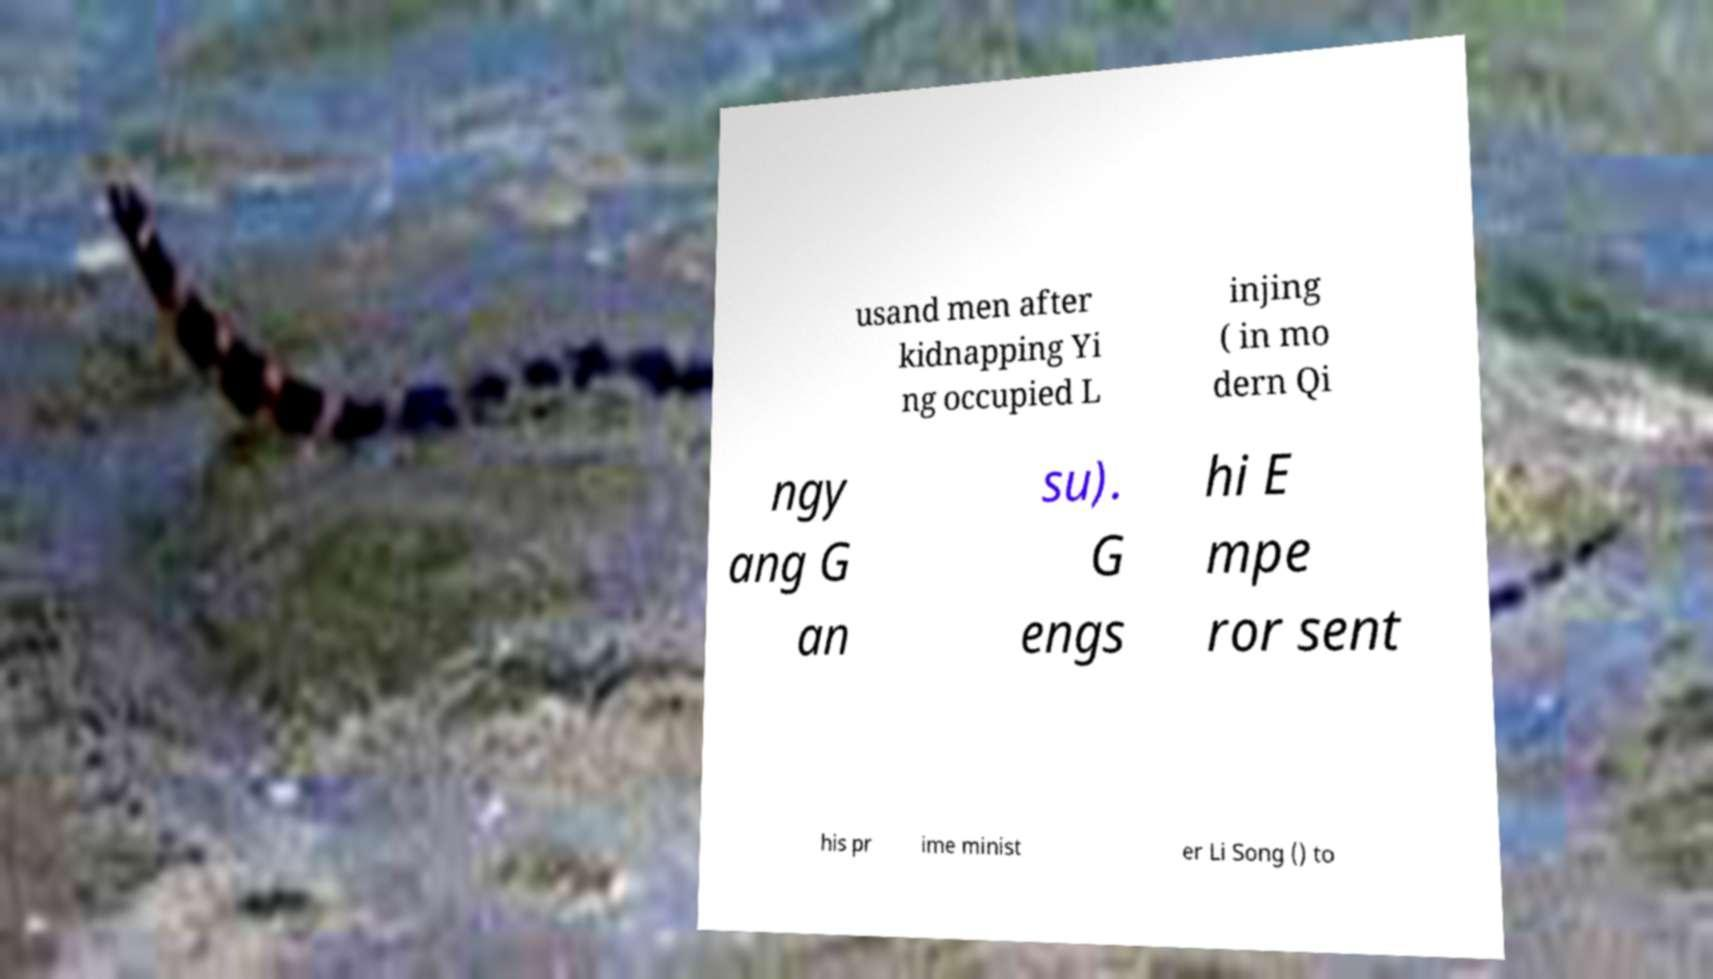I need the written content from this picture converted into text. Can you do that? usand men after kidnapping Yi ng occupied L injing ( in mo dern Qi ngy ang G an su). G engs hi E mpe ror sent his pr ime minist er Li Song () to 